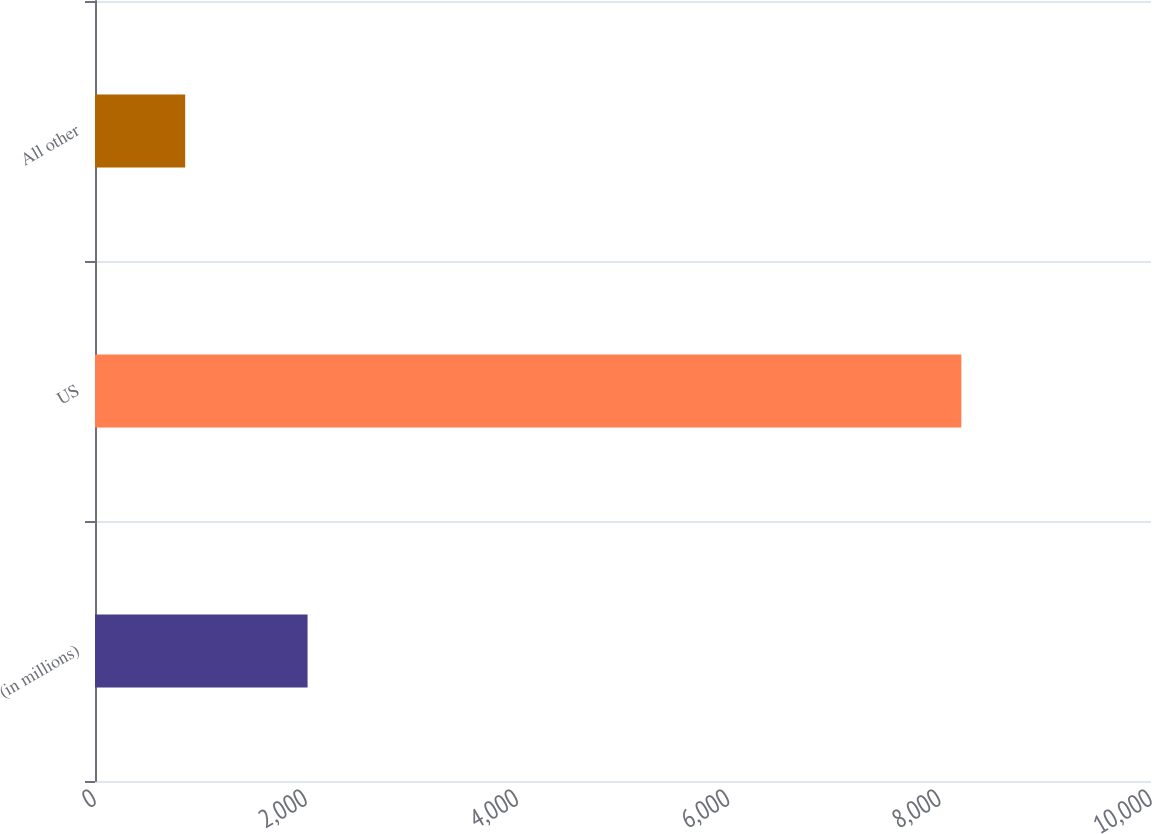Convert chart. <chart><loc_0><loc_0><loc_500><loc_500><bar_chart><fcel>(in millions)<fcel>US<fcel>All other<nl><fcel>2013<fcel>8204<fcel>854<nl></chart> 